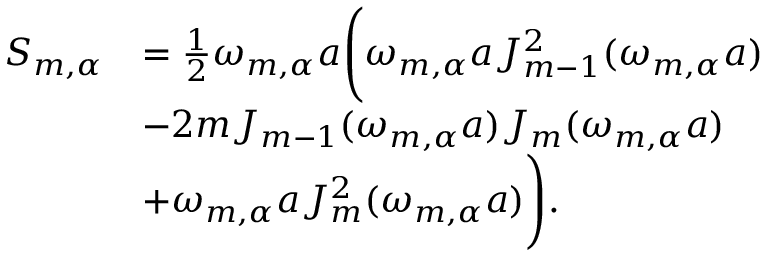<formula> <loc_0><loc_0><loc_500><loc_500>\begin{array} { r l } { S _ { m , \alpha } } & { = \frac { 1 } { 2 } \omega _ { m , \alpha } a \left ( \omega _ { m , \alpha } a J _ { m - 1 } ^ { 2 } ( \omega _ { m , \alpha } a ) } \\ & { - 2 m J _ { m - 1 } ( \omega _ { m , \alpha } a ) J _ { m } ( \omega _ { m , \alpha } a ) } \\ & { + \omega _ { m , \alpha } a J _ { m } ^ { 2 } ( \omega _ { m , \alpha } a ) \right ) . } \end{array}</formula> 